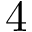<formula> <loc_0><loc_0><loc_500><loc_500>4</formula> 